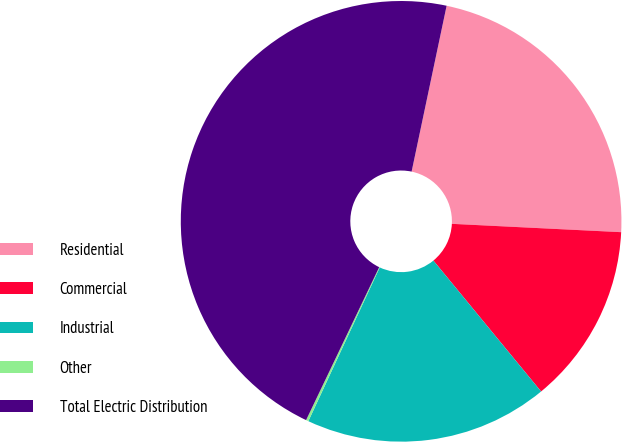Convert chart. <chart><loc_0><loc_0><loc_500><loc_500><pie_chart><fcel>Residential<fcel>Commercial<fcel>Industrial<fcel>Other<fcel>Total Electric Distribution<nl><fcel>22.47%<fcel>13.26%<fcel>17.87%<fcel>0.18%<fcel>46.21%<nl></chart> 